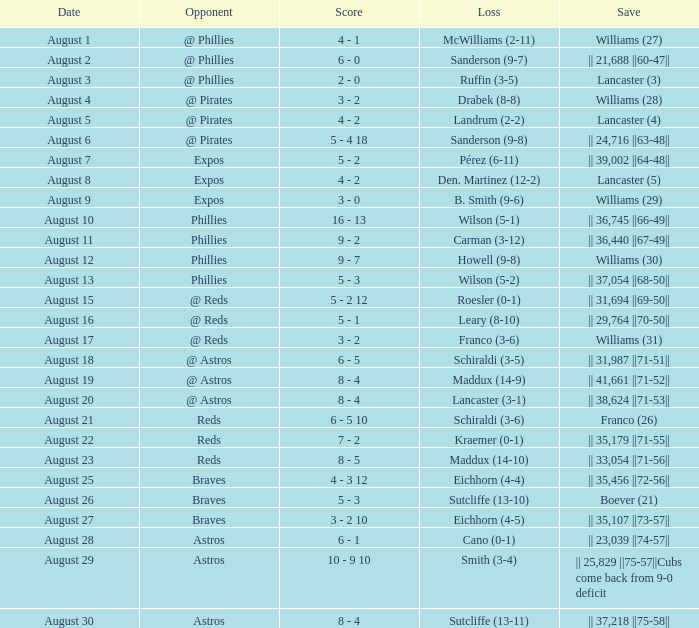Provide the save score for lancaster (3). 2 - 0. 